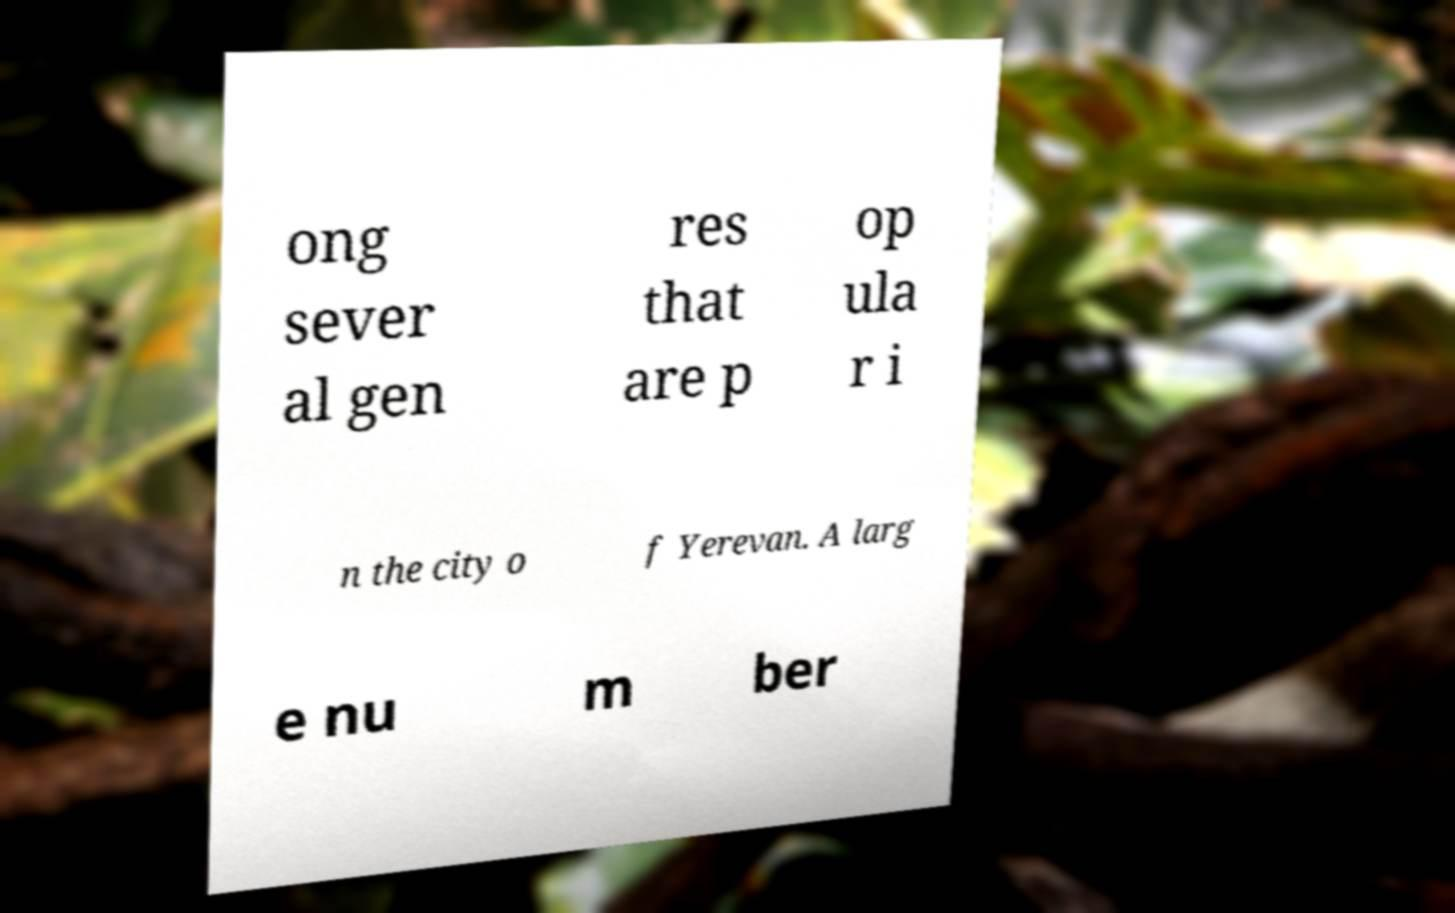Can you accurately transcribe the text from the provided image for me? ong sever al gen res that are p op ula r i n the city o f Yerevan. A larg e nu m ber 